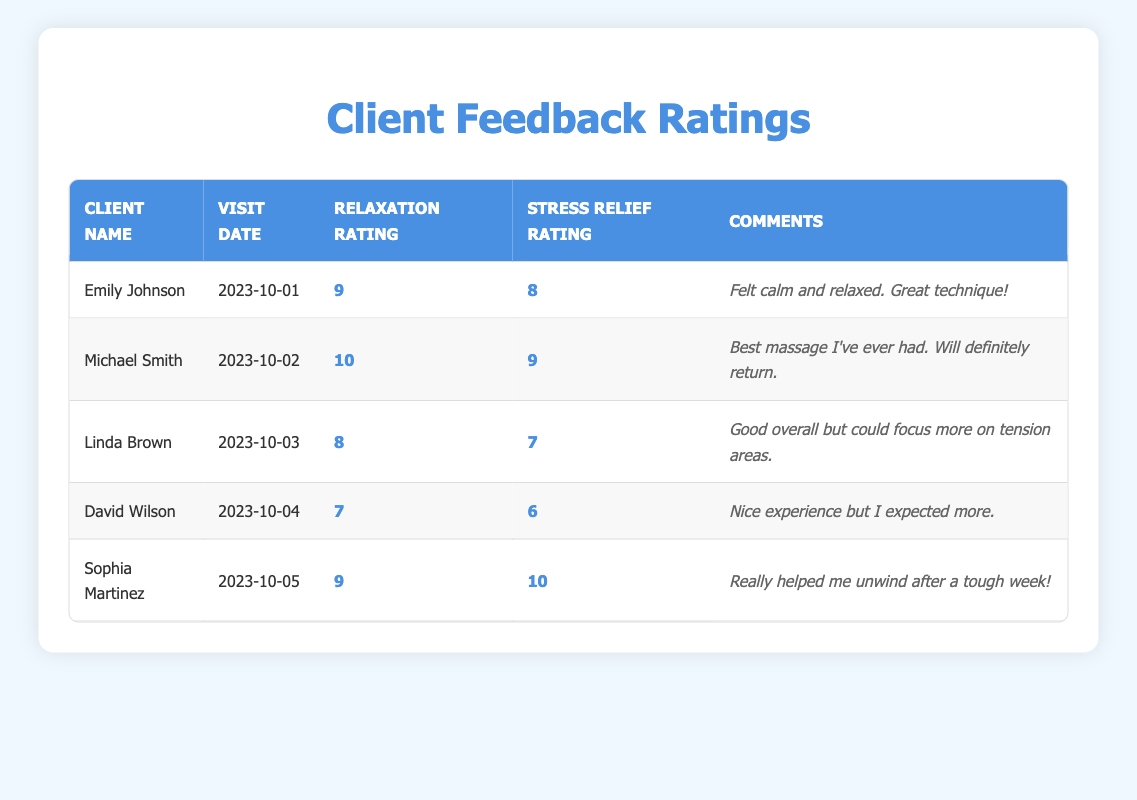What is the highest relaxation rating recorded? Looking at the "Relaxation Rating" column, the highest value is found for Michael Smith with a rating of 10.
Answer: 10 What comments did Sophia Martinez leave? The comments provided in the table for Sophia Martinez state: "Really helped me unwind after a tough week!"
Answer: Really helped me unwind after a tough week! How many clients rated their relaxation experience above 8? By inspecting the "Relaxation Rating," we see that Emily Johnson (9), Michael Smith (10), and Sophia Martinez (9) rated above 8, totaling 3 clients.
Answer: 3 What is the average stress relief rating of the clients? To find the average, sum the stress relief ratings: (8 + 9 + 7 + 6 + 10) = 40, and divide by the number of clients, which is 5. Therefore, the average is 40/5 = 8.
Answer: 8 Did any client rate their stress relief experience lower than their relaxation experience? By analyzing each client's ratings, David Wilson rated his relaxation at 7 and stress relief at 6, indicating a lower stress relief rating. Thus, the statement is true.
Answer: Yes Which client had the lowest stress relief rating, and what was it? In reviewing the stress relief ratings, David Wilson has the lowest rating at 6.
Answer: David Wilson, 6 What is the difference between the highest and lowest relaxation ratings? The highest relaxation rating is 10 (Michael Smith) and the lowest is 7 (David Wilson). The difference is 10 - 7 = 3.
Answer: 3 Which client provided feedback that noted a specific technique as "great"? The feedback from Emily Johnson included the comment "Great technique!" indicating she appreciated the method used during her massage.
Answer: Emily Johnson 